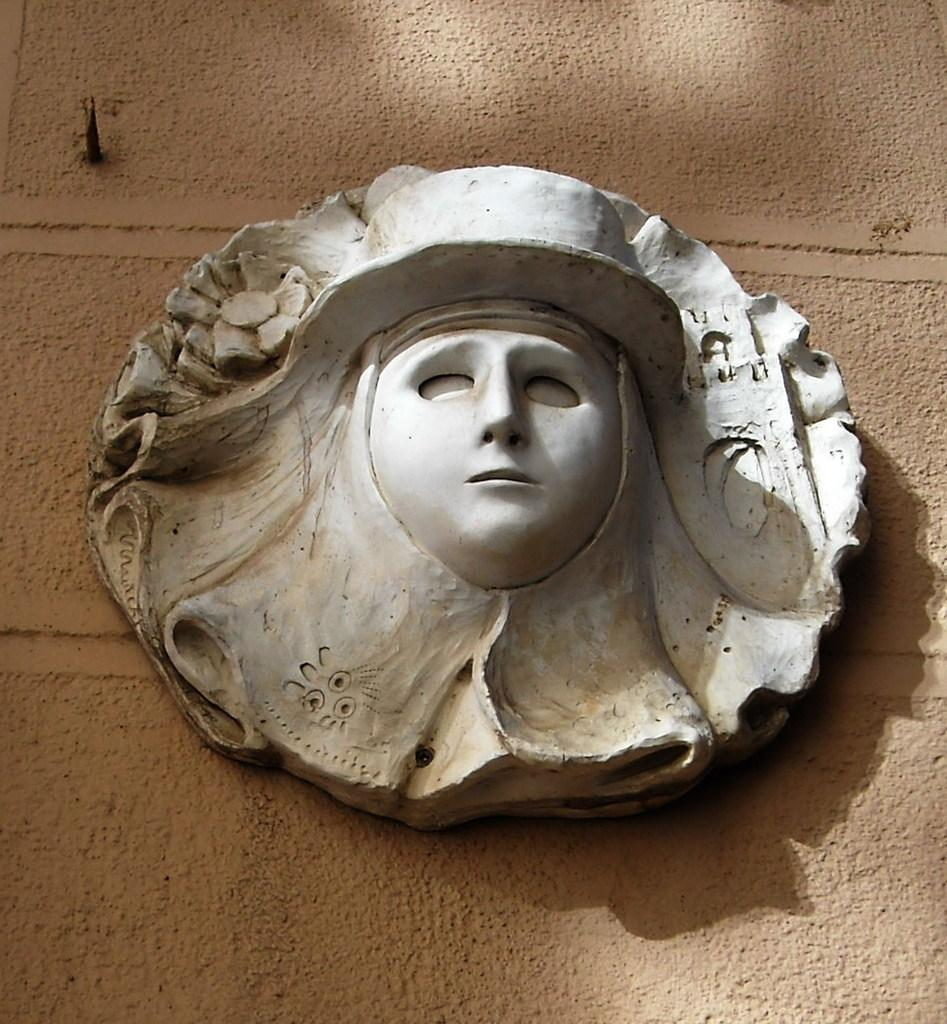What is the main subject of the image? The main subject of the image is a sculpture on the wall. Can you describe the sculpture in the image? Unfortunately, the facts provided do not give any details about the sculpture's appearance or design. What type of material might the sculpture be made of? The facts provided do not give any information about the material used to create the sculpture. How does the sculpture compare to the song playing in the background of the image? There is no mention of a song playing in the background of the image, so we cannot compare the sculpture to a song. 